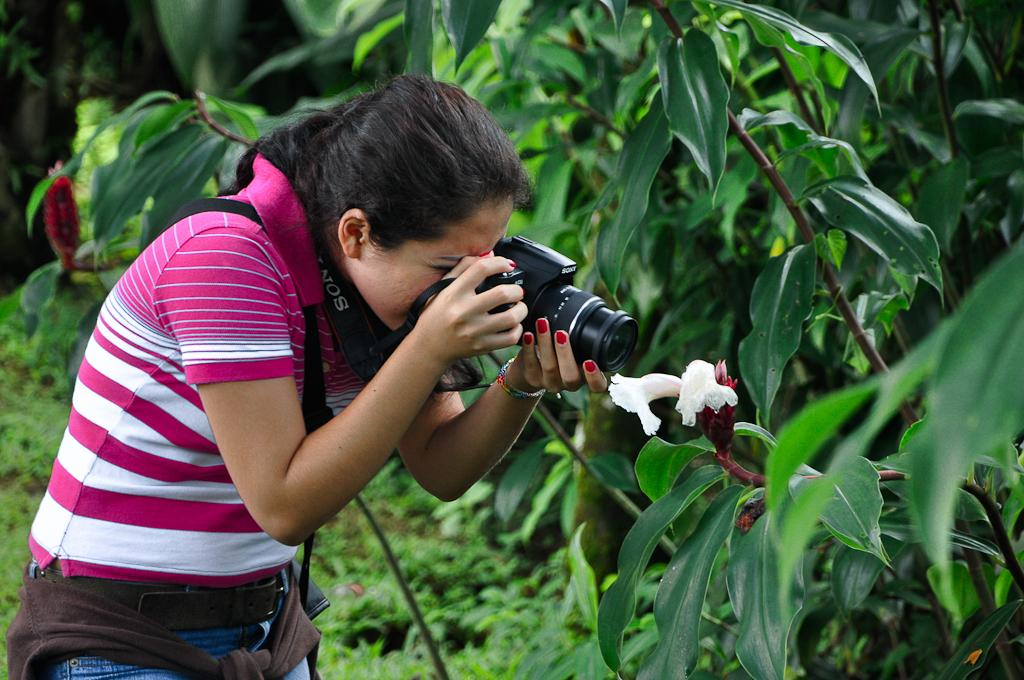Who is the main subject in the image? There is a woman in the image. What is the woman holding in the image? The woman is holding a camera. What is the woman doing with the camera? The woman is taking a snap of a flower. Can you describe the object the woman is photographing? The flower is part of a plant. What type of industry can be seen in the background of the image? There is no industry visible in the image; it features a woman taking a snap of a flower. Which direction is the woman facing in the image? The direction the woman is facing cannot be determined from the image alone. 